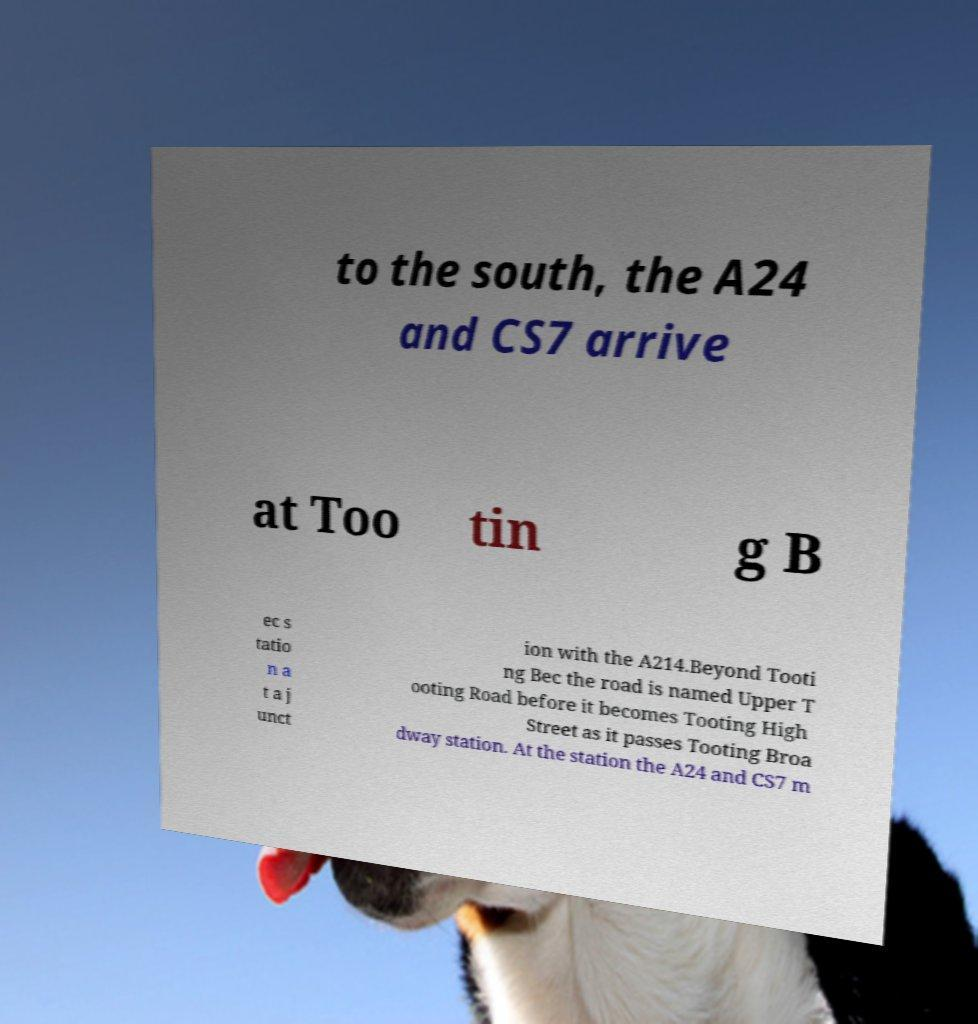Could you extract and type out the text from this image? to the south, the A24 and CS7 arrive at Too tin g B ec s tatio n a t a j unct ion with the A214.Beyond Tooti ng Bec the road is named Upper T ooting Road before it becomes Tooting High Street as it passes Tooting Broa dway station. At the station the A24 and CS7 m 